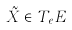Convert formula to latex. <formula><loc_0><loc_0><loc_500><loc_500>\tilde { X } \in T _ { e } E</formula> 